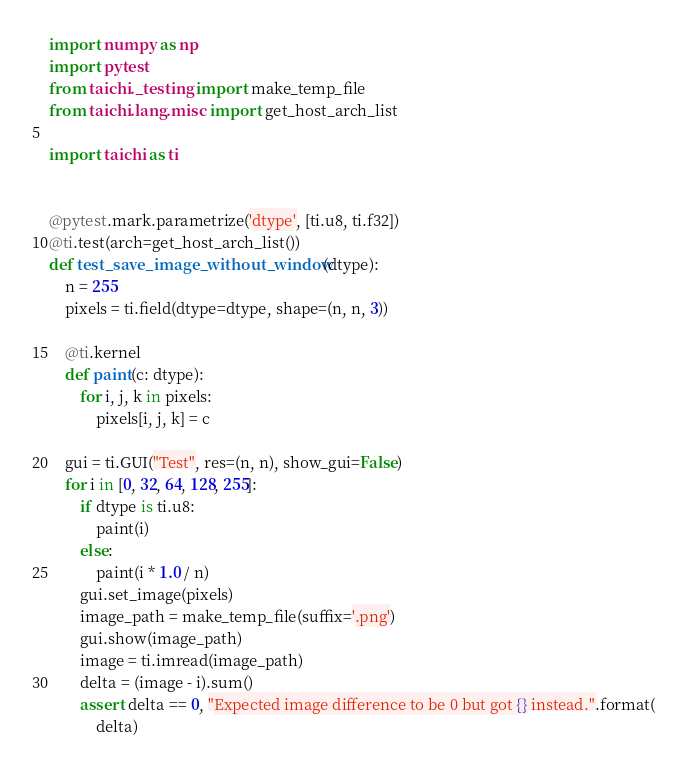Convert code to text. <code><loc_0><loc_0><loc_500><loc_500><_Python_>import numpy as np
import pytest
from taichi._testing import make_temp_file
from taichi.lang.misc import get_host_arch_list

import taichi as ti


@pytest.mark.parametrize('dtype', [ti.u8, ti.f32])
@ti.test(arch=get_host_arch_list())
def test_save_image_without_window(dtype):
    n = 255
    pixels = ti.field(dtype=dtype, shape=(n, n, 3))

    @ti.kernel
    def paint(c: dtype):
        for i, j, k in pixels:
            pixels[i, j, k] = c

    gui = ti.GUI("Test", res=(n, n), show_gui=False)
    for i in [0, 32, 64, 128, 255]:
        if dtype is ti.u8:
            paint(i)
        else:
            paint(i * 1.0 / n)
        gui.set_image(pixels)
        image_path = make_temp_file(suffix='.png')
        gui.show(image_path)
        image = ti.imread(image_path)
        delta = (image - i).sum()
        assert delta == 0, "Expected image difference to be 0 but got {} instead.".format(
            delta)
</code> 